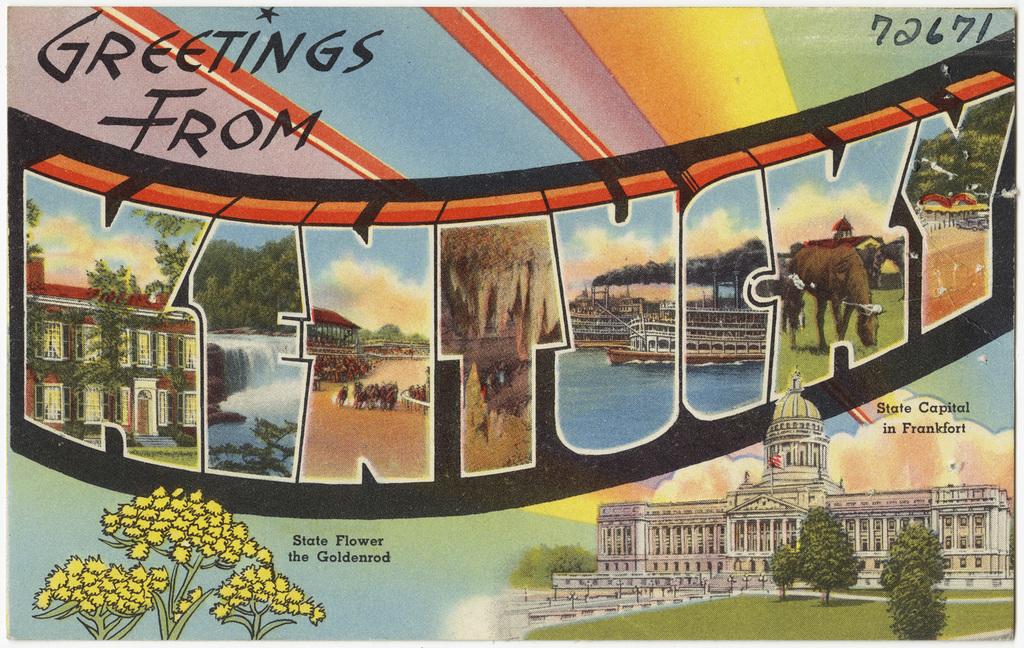From where is the card offering greetings?
Offer a terse response. Kentucky. What is the number of the top right corner?
Give a very brief answer. 72671. 